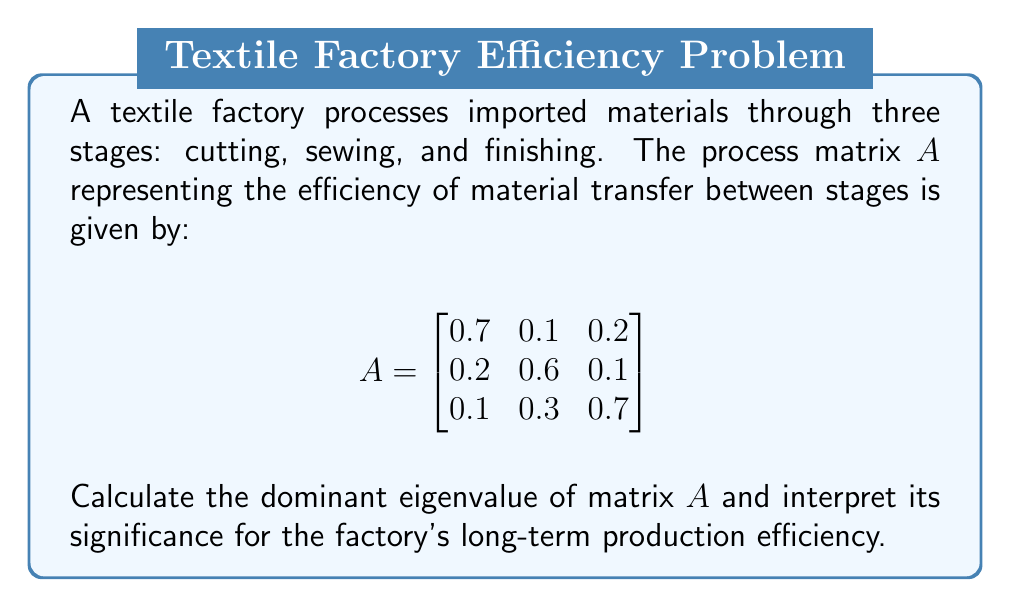Help me with this question. 1) To find the eigenvalues, we solve the characteristic equation:
   $\det(A - \lambda I) = 0$

2) Expanding the determinant:
   $$(0.7-\lambda)(0.6-\lambda)(0.7-\lambda) - 0.1 \cdot 0.1 \cdot 0.3 - 0.2 \cdot 0.2 \cdot 0.3 - 0.1 \cdot 0.1 \cdot 0.2 + 0.1 \cdot 0.2 \cdot 0.3 + 0.2 \cdot 0.1 \cdot 0.1 = 0$$

3) Simplifying:
   $$-\lambda^3 + 2\lambda^2 - 1.09\lambda + 0.167 = 0$$

4) Solving this cubic equation (using a computer algebra system or numerical methods) gives us the eigenvalues:
   $$\lambda_1 \approx 1.0392, \lambda_2 \approx 0.5304, \lambda_3 \approx 0.4304$$

5) The dominant eigenvalue is the largest in magnitude: $\lambda_1 \approx 1.0392$

6) Interpretation: The dominant eigenvalue being greater than 1 indicates that the production process is slightly expansive. In the long run, for each unit of material input, the factory will produce approximately 1.0392 units of output. This suggests a small but positive growth in production efficiency over time.
Answer: $\lambda_1 \approx 1.0392$; indicates slight production growth 